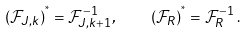Convert formula to latex. <formula><loc_0><loc_0><loc_500><loc_500>( { \mathcal { F } } _ { J , k } ) ^ { ^ { * } } = { \mathcal { F } } _ { J , k + 1 } ^ { - 1 } , \quad ( { \mathcal { F } } _ { R } ) ^ { ^ { * } } = { \mathcal { F } } _ { R } ^ { - 1 } \, .</formula> 